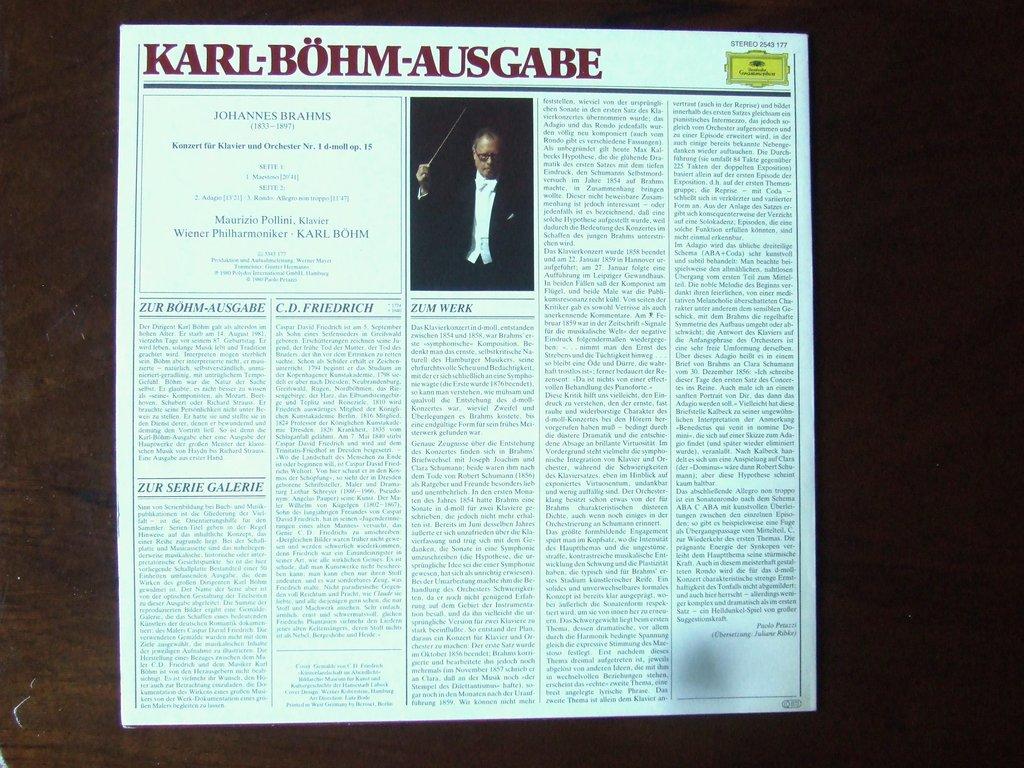What composer is listed at the top of the box in the upper left corner?
Offer a terse response. Johannes brahms. 